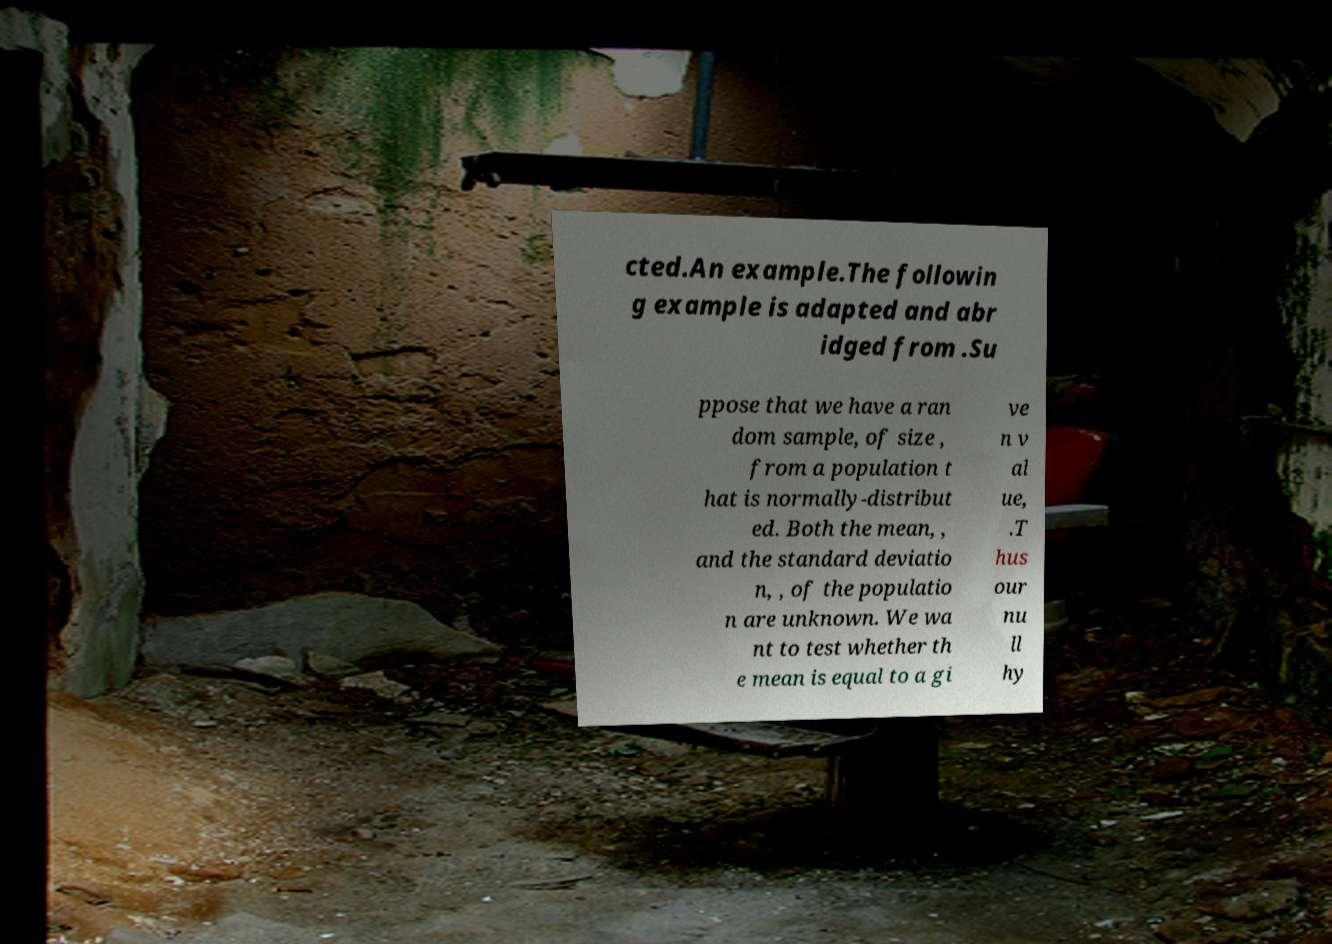Can you read and provide the text displayed in the image?This photo seems to have some interesting text. Can you extract and type it out for me? cted.An example.The followin g example is adapted and abr idged from .Su ppose that we have a ran dom sample, of size , from a population t hat is normally-distribut ed. Both the mean, , and the standard deviatio n, , of the populatio n are unknown. We wa nt to test whether th e mean is equal to a gi ve n v al ue, .T hus our nu ll hy 